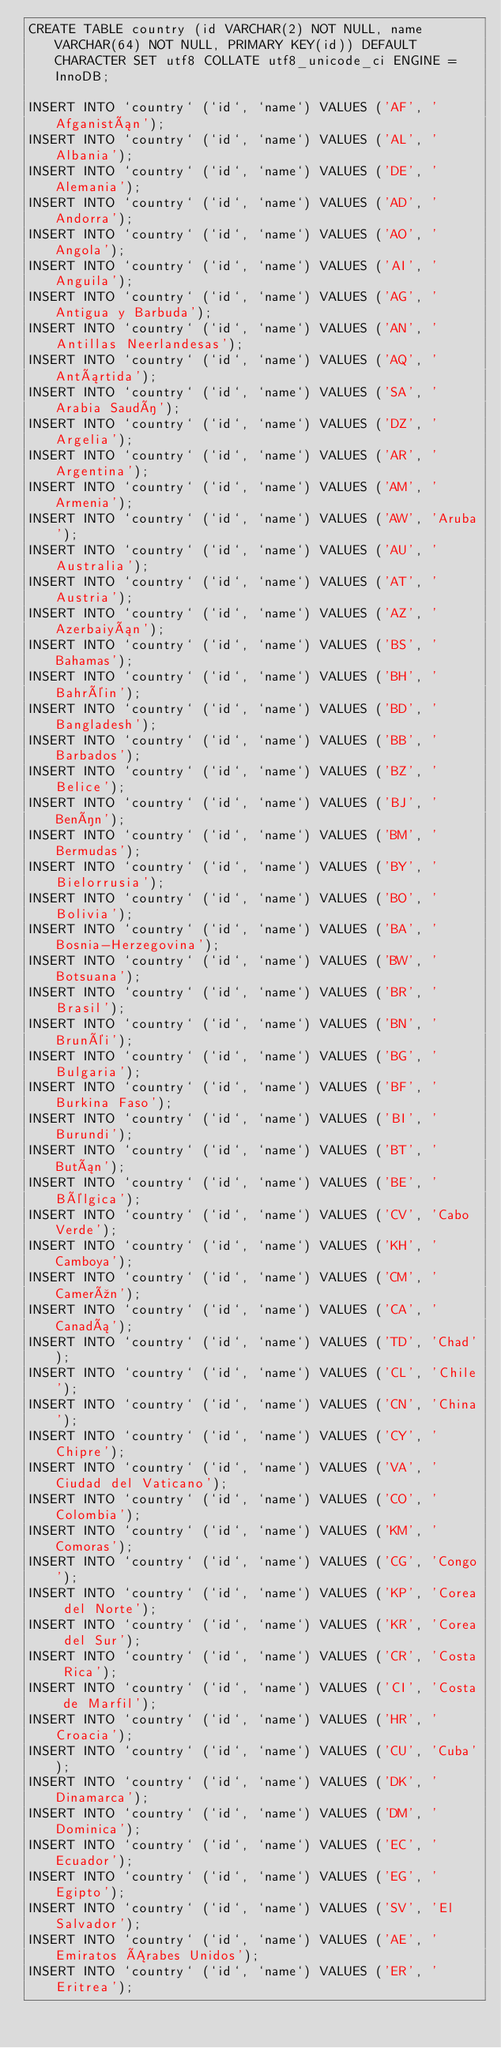<code> <loc_0><loc_0><loc_500><loc_500><_SQL_>CREATE TABLE country (id VARCHAR(2) NOT NULL, name VARCHAR(64) NOT NULL, PRIMARY KEY(id)) DEFAULT CHARACTER SET utf8 COLLATE utf8_unicode_ci ENGINE = InnoDB;

INSERT INTO `country` (`id`, `name`) VALUES ('AF', 'Afganistán');
INSERT INTO `country` (`id`, `name`) VALUES ('AL', 'Albania');
INSERT INTO `country` (`id`, `name`) VALUES ('DE', 'Alemania');
INSERT INTO `country` (`id`, `name`) VALUES ('AD', 'Andorra');
INSERT INTO `country` (`id`, `name`) VALUES ('AO', 'Angola');
INSERT INTO `country` (`id`, `name`) VALUES ('AI', 'Anguila');
INSERT INTO `country` (`id`, `name`) VALUES ('AG', 'Antigua y Barbuda');
INSERT INTO `country` (`id`, `name`) VALUES ('AN', 'Antillas Neerlandesas');
INSERT INTO `country` (`id`, `name`) VALUES ('AQ', 'Antártida');
INSERT INTO `country` (`id`, `name`) VALUES ('SA', 'Arabia Saudí');
INSERT INTO `country` (`id`, `name`) VALUES ('DZ', 'Argelia');
INSERT INTO `country` (`id`, `name`) VALUES ('AR', 'Argentina');
INSERT INTO `country` (`id`, `name`) VALUES ('AM', 'Armenia');
INSERT INTO `country` (`id`, `name`) VALUES ('AW', 'Aruba');
INSERT INTO `country` (`id`, `name`) VALUES ('AU', 'Australia');
INSERT INTO `country` (`id`, `name`) VALUES ('AT', 'Austria');
INSERT INTO `country` (`id`, `name`) VALUES ('AZ', 'Azerbaiyán');
INSERT INTO `country` (`id`, `name`) VALUES ('BS', 'Bahamas');
INSERT INTO `country` (`id`, `name`) VALUES ('BH', 'Bahréin');
INSERT INTO `country` (`id`, `name`) VALUES ('BD', 'Bangladesh');
INSERT INTO `country` (`id`, `name`) VALUES ('BB', 'Barbados');
INSERT INTO `country` (`id`, `name`) VALUES ('BZ', 'Belice');
INSERT INTO `country` (`id`, `name`) VALUES ('BJ', 'Benín');
INSERT INTO `country` (`id`, `name`) VALUES ('BM', 'Bermudas');
INSERT INTO `country` (`id`, `name`) VALUES ('BY', 'Bielorrusia');
INSERT INTO `country` (`id`, `name`) VALUES ('BO', 'Bolivia');
INSERT INTO `country` (`id`, `name`) VALUES ('BA', 'Bosnia-Herzegovina');
INSERT INTO `country` (`id`, `name`) VALUES ('BW', 'Botsuana');
INSERT INTO `country` (`id`, `name`) VALUES ('BR', 'Brasil');
INSERT INTO `country` (`id`, `name`) VALUES ('BN', 'Brunéi');
INSERT INTO `country` (`id`, `name`) VALUES ('BG', 'Bulgaria');
INSERT INTO `country` (`id`, `name`) VALUES ('BF', 'Burkina Faso');
INSERT INTO `country` (`id`, `name`) VALUES ('BI', 'Burundi');
INSERT INTO `country` (`id`, `name`) VALUES ('BT', 'Bután');
INSERT INTO `country` (`id`, `name`) VALUES ('BE', 'Bélgica');
INSERT INTO `country` (`id`, `name`) VALUES ('CV', 'Cabo Verde');
INSERT INTO `country` (`id`, `name`) VALUES ('KH', 'Camboya');
INSERT INTO `country` (`id`, `name`) VALUES ('CM', 'Camerún');
INSERT INTO `country` (`id`, `name`) VALUES ('CA', 'Canadá');
INSERT INTO `country` (`id`, `name`) VALUES ('TD', 'Chad');
INSERT INTO `country` (`id`, `name`) VALUES ('CL', 'Chile');
INSERT INTO `country` (`id`, `name`) VALUES ('CN', 'China');
INSERT INTO `country` (`id`, `name`) VALUES ('CY', 'Chipre');
INSERT INTO `country` (`id`, `name`) VALUES ('VA', 'Ciudad del Vaticano');
INSERT INTO `country` (`id`, `name`) VALUES ('CO', 'Colombia');
INSERT INTO `country` (`id`, `name`) VALUES ('KM', 'Comoras');
INSERT INTO `country` (`id`, `name`) VALUES ('CG', 'Congo');
INSERT INTO `country` (`id`, `name`) VALUES ('KP', 'Corea del Norte');
INSERT INTO `country` (`id`, `name`) VALUES ('KR', 'Corea del Sur');
INSERT INTO `country` (`id`, `name`) VALUES ('CR', 'Costa Rica');
INSERT INTO `country` (`id`, `name`) VALUES ('CI', 'Costa de Marfil');
INSERT INTO `country` (`id`, `name`) VALUES ('HR', 'Croacia');
INSERT INTO `country` (`id`, `name`) VALUES ('CU', 'Cuba');
INSERT INTO `country` (`id`, `name`) VALUES ('DK', 'Dinamarca');
INSERT INTO `country` (`id`, `name`) VALUES ('DM', 'Dominica');
INSERT INTO `country` (`id`, `name`) VALUES ('EC', 'Ecuador');
INSERT INTO `country` (`id`, `name`) VALUES ('EG', 'Egipto');
INSERT INTO `country` (`id`, `name`) VALUES ('SV', 'El Salvador');
INSERT INTO `country` (`id`, `name`) VALUES ('AE', 'Emiratos Árabes Unidos');
INSERT INTO `country` (`id`, `name`) VALUES ('ER', 'Eritrea');</code> 